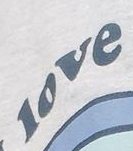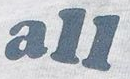Identify the words shown in these images in order, separated by a semicolon. love; all 